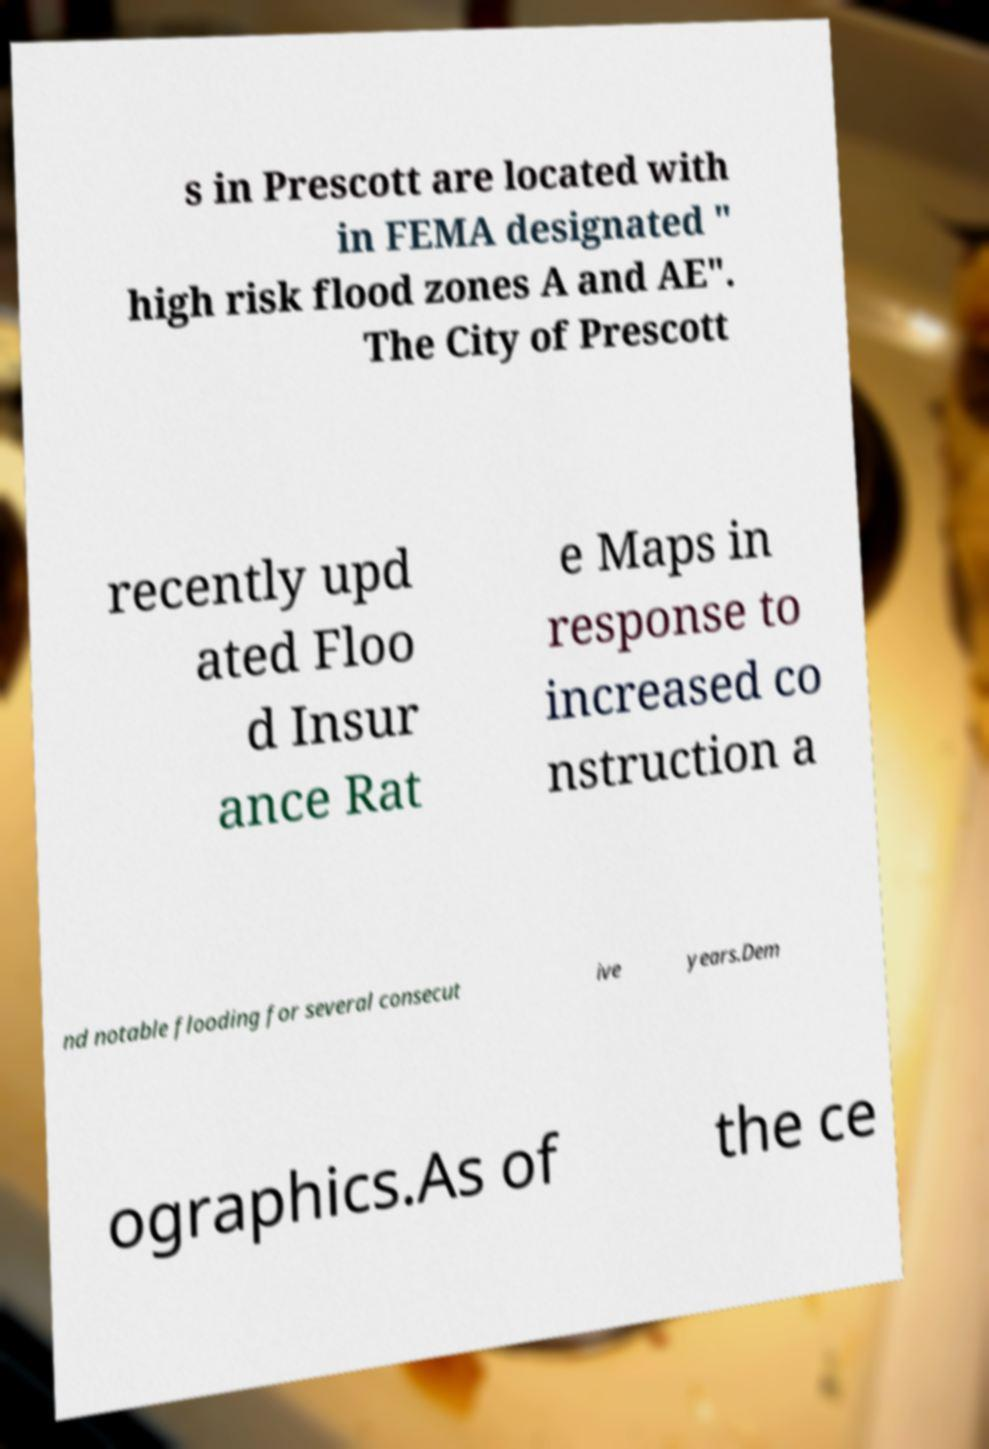Please identify and transcribe the text found in this image. s in Prescott are located with in FEMA designated " high risk flood zones A and AE". The City of Prescott recently upd ated Floo d Insur ance Rat e Maps in response to increased co nstruction a nd notable flooding for several consecut ive years.Dem ographics.As of the ce 